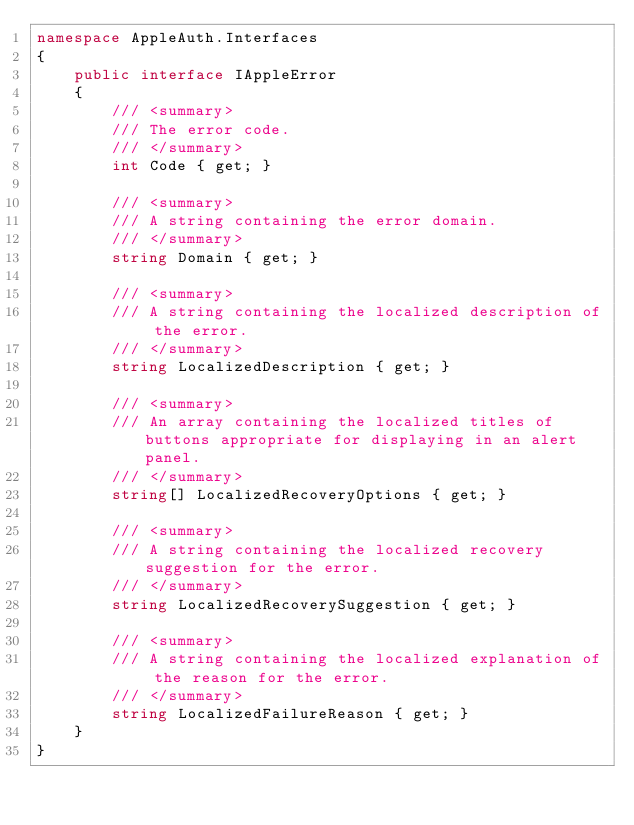Convert code to text. <code><loc_0><loc_0><loc_500><loc_500><_C#_>namespace AppleAuth.Interfaces
{
    public interface IAppleError
    {
        /// <summary>
        /// The error code.
        /// </summary>
        int Code { get; }

        /// <summary>
        /// A string containing the error domain.
        /// </summary>
        string Domain { get; }

        /// <summary>
        /// A string containing the localized description of the error.
        /// </summary>
        string LocalizedDescription { get; }

        /// <summary>
        /// An array containing the localized titles of buttons appropriate for displaying in an alert panel.
        /// </summary>
        string[] LocalizedRecoveryOptions { get; }

        /// <summary>
        /// A string containing the localized recovery suggestion for the error.
        /// </summary>
        string LocalizedRecoverySuggestion { get; }

        /// <summary>
        /// A string containing the localized explanation of the reason for the error.
        /// </summary>
        string LocalizedFailureReason { get; }
    }
}
</code> 